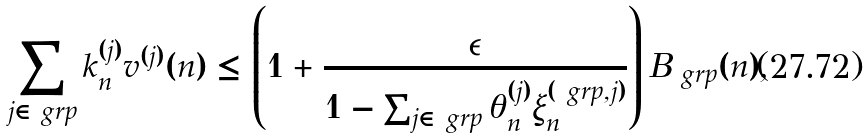<formula> <loc_0><loc_0><loc_500><loc_500>\sum _ { j \in \ g r p } k _ { n } ^ { ( j ) } v ^ { ( j ) } ( n ) & \leq \left ( 1 + \frac { \epsilon } { 1 - \sum _ { j \in \ g r p } \theta _ { n } ^ { ( j ) } \xi _ { n } ^ { ( \ g r p , j ) } } \right ) B _ { \ g r p } ( n ) ,</formula> 